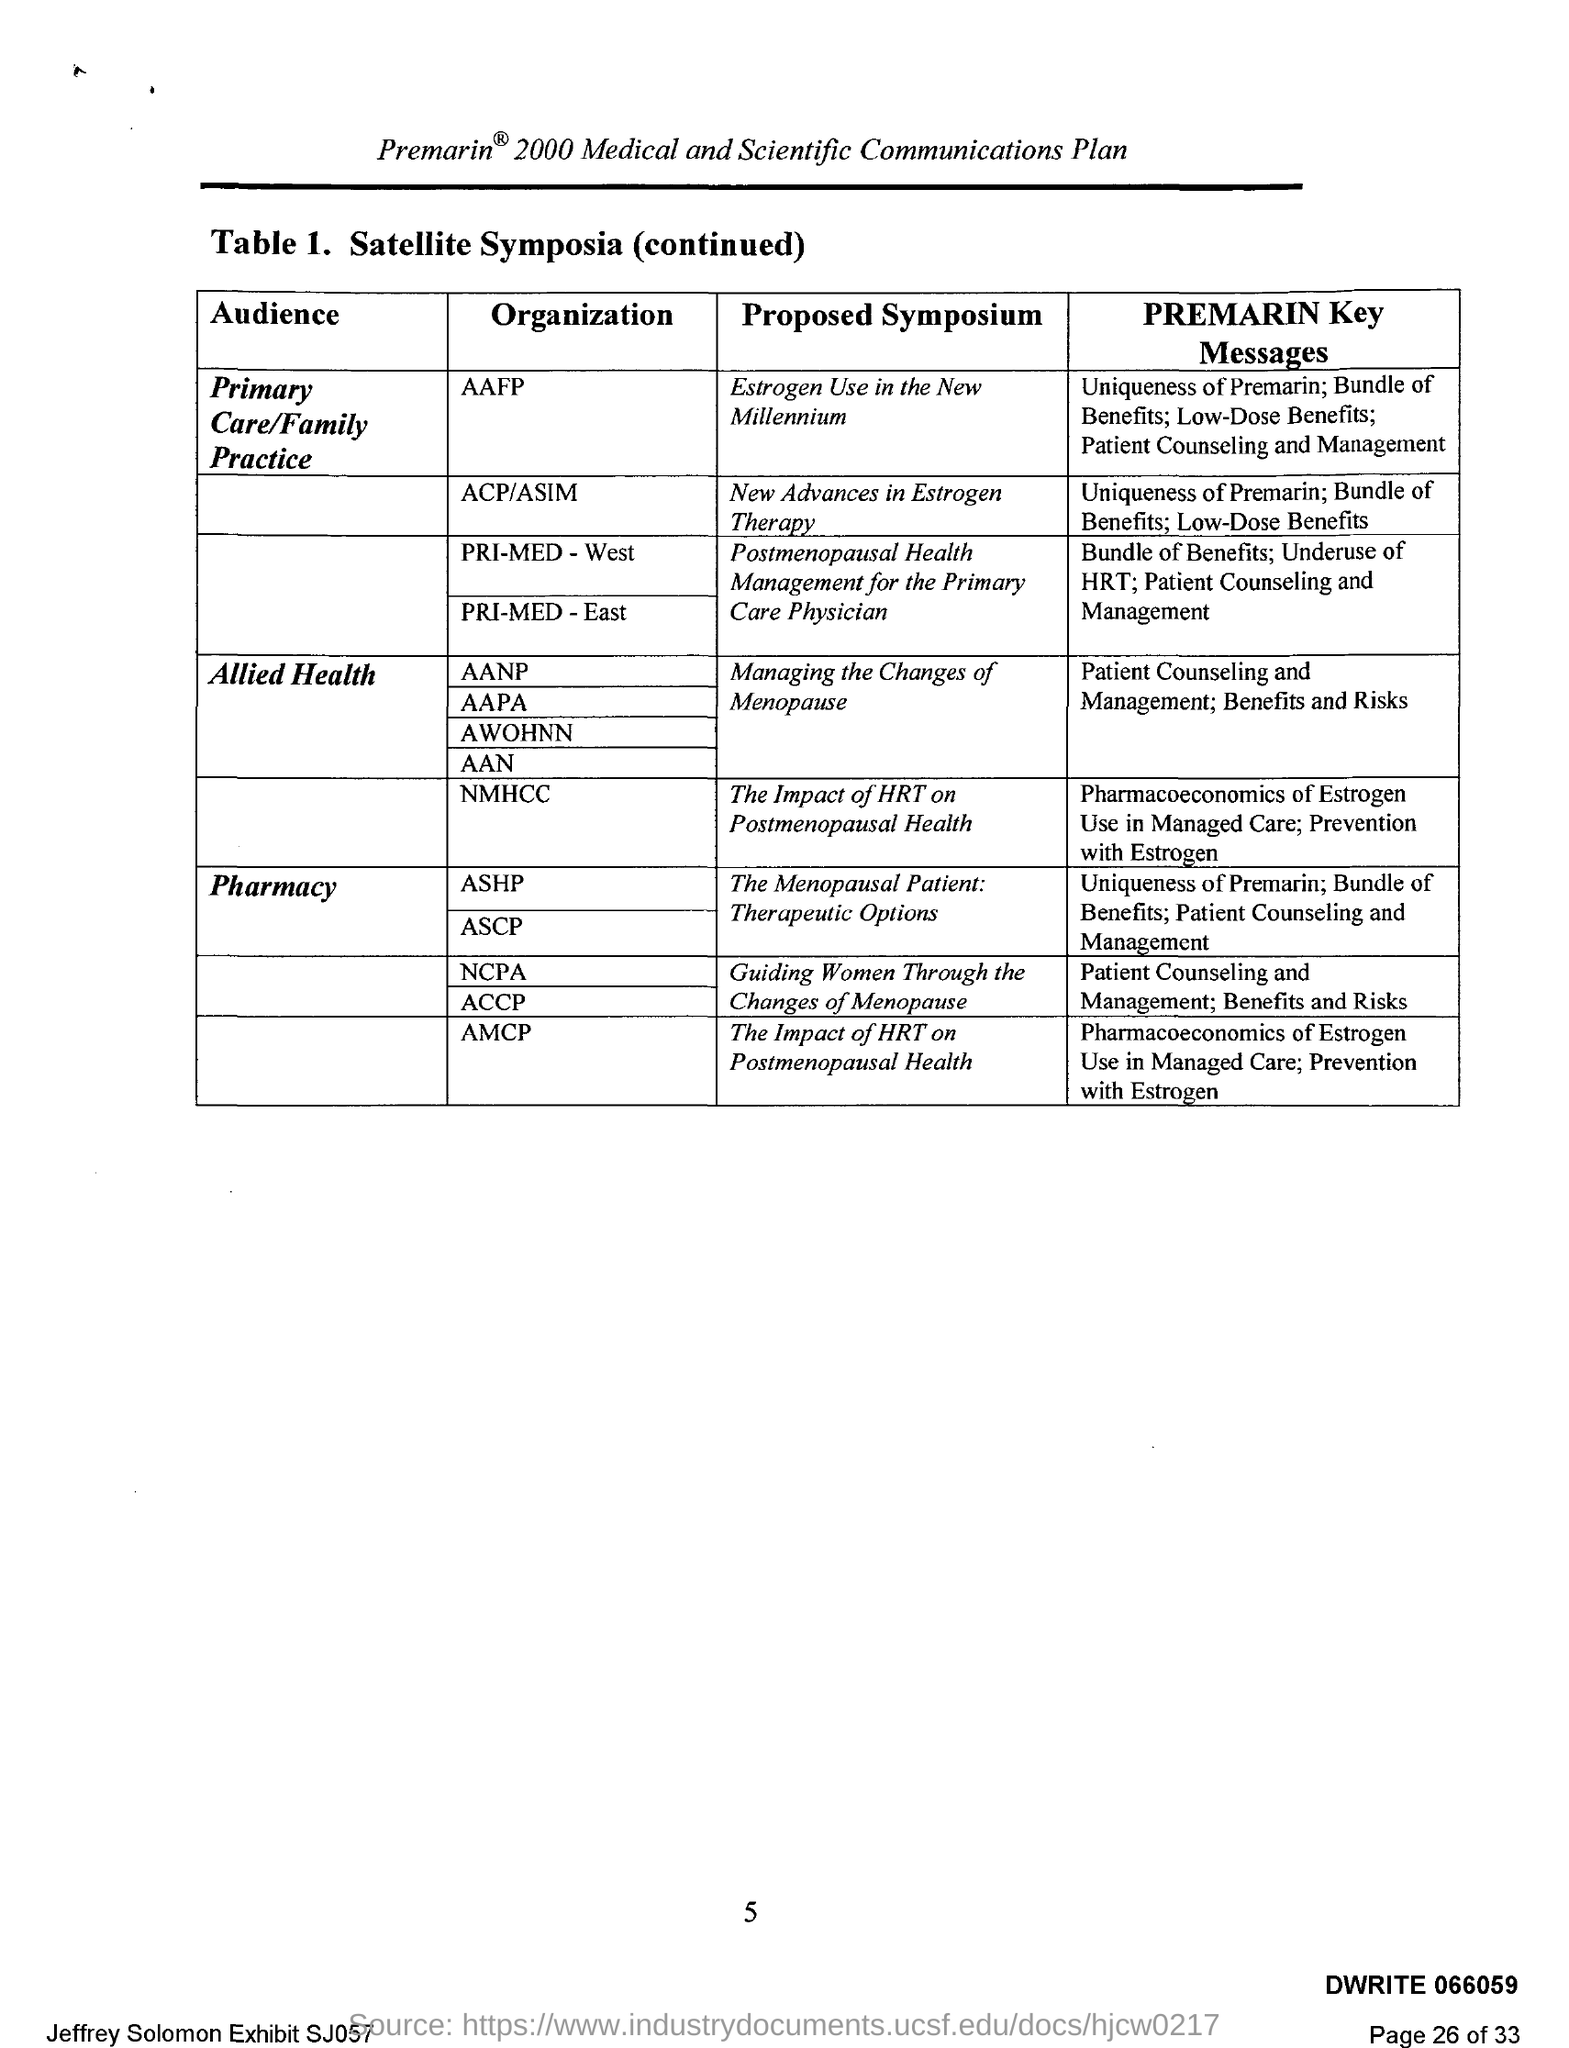List a handful of essential elements in this visual. The American Academy of Family Physicians has proposed a symposium on the topic of "estrogen use in the new millennium. The American College of Physicians (ACP) and the American Society of Internal Medicine (ASIM) have proposed a symposium on "New Advances in Estrogen Therapy. 